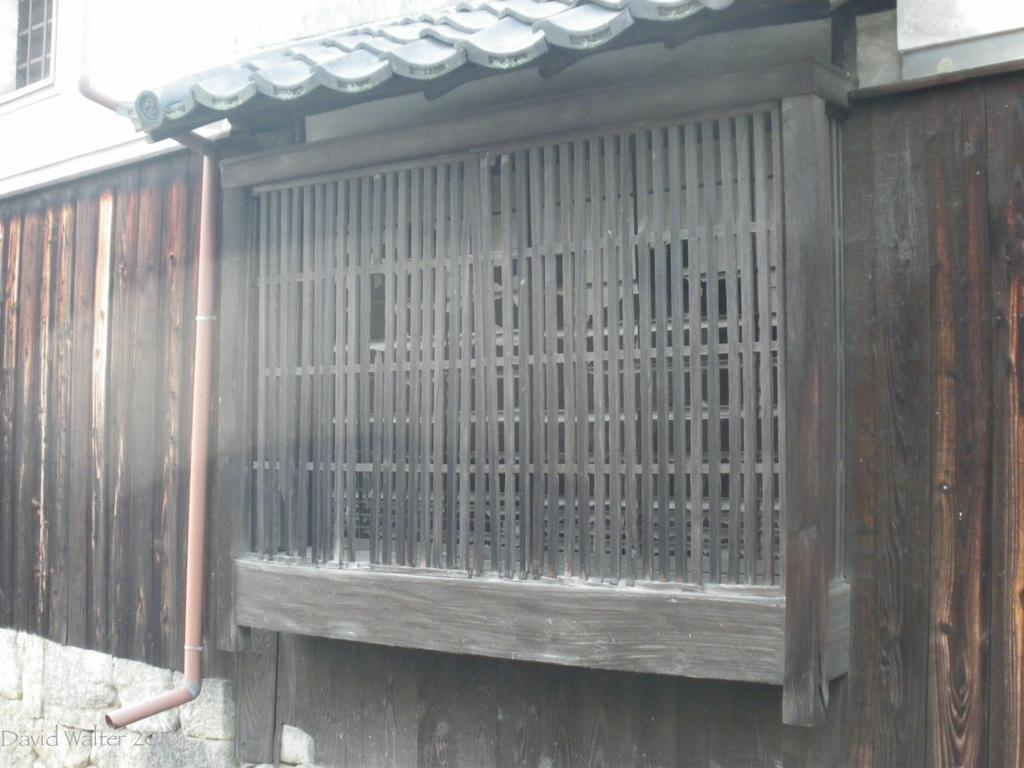What type of structure is visible in the image? There is a building in the image. What material is used for the window in the building? The window in the building is made of wood. What other object can be seen in the image? There is a pipe in the image. What type of wall is present in the image? There is a wooden wall in the image. What is the best route to reach the harbor from the building in the image? There is no information about a harbor or a route in the image, so it is not possible to answer this question. 